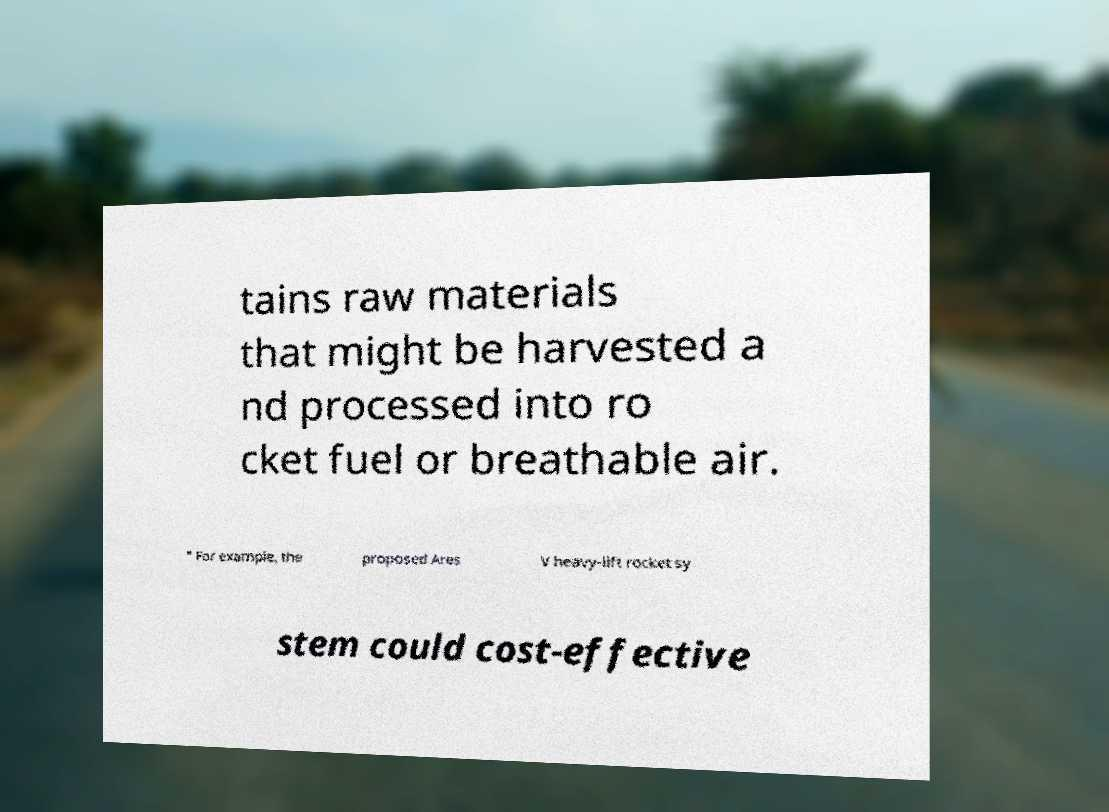Can you accurately transcribe the text from the provided image for me? tains raw materials that might be harvested a nd processed into ro cket fuel or breathable air. " For example, the proposed Ares V heavy-lift rocket sy stem could cost-effective 